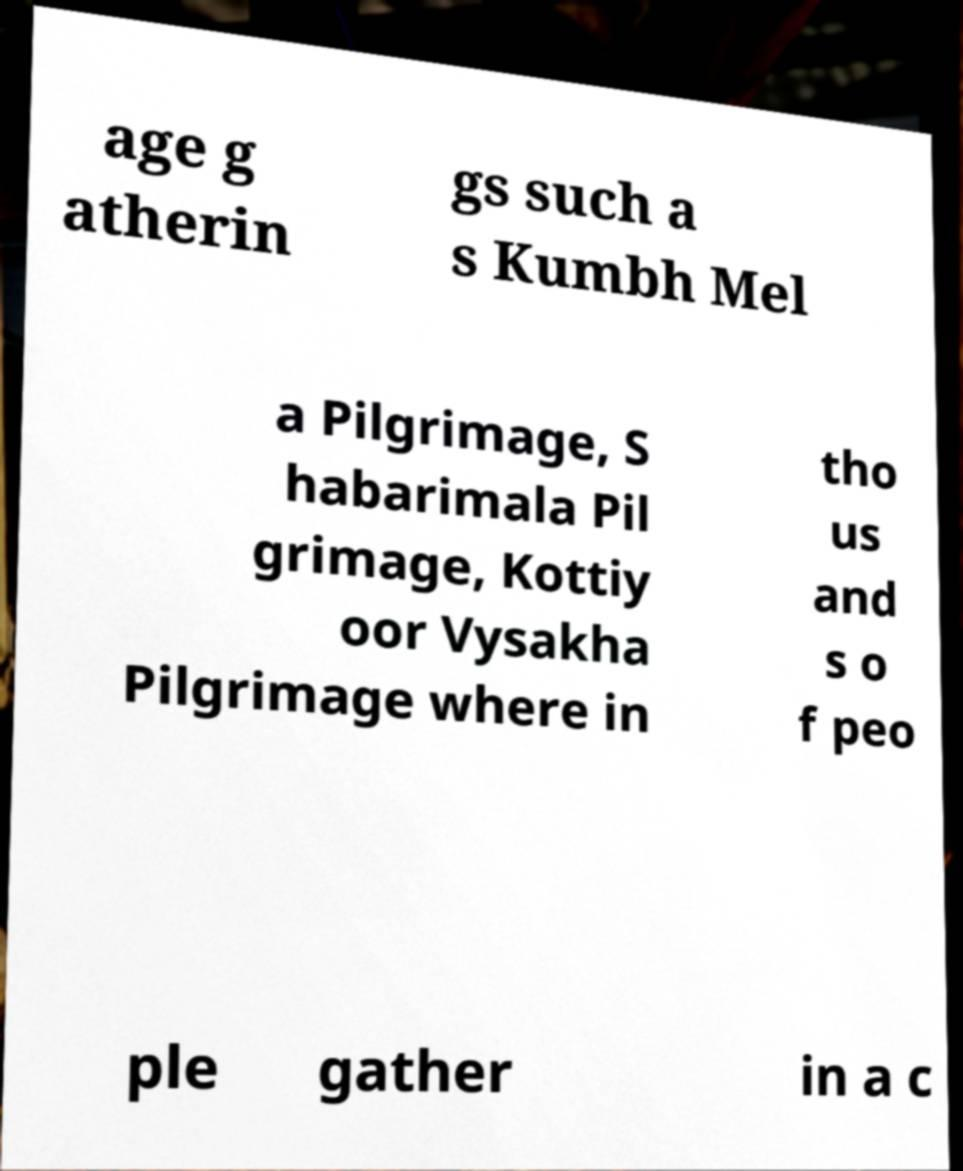For documentation purposes, I need the text within this image transcribed. Could you provide that? age g atherin gs such a s Kumbh Mel a Pilgrimage, S habarimala Pil grimage, Kottiy oor Vysakha Pilgrimage where in tho us and s o f peo ple gather in a c 